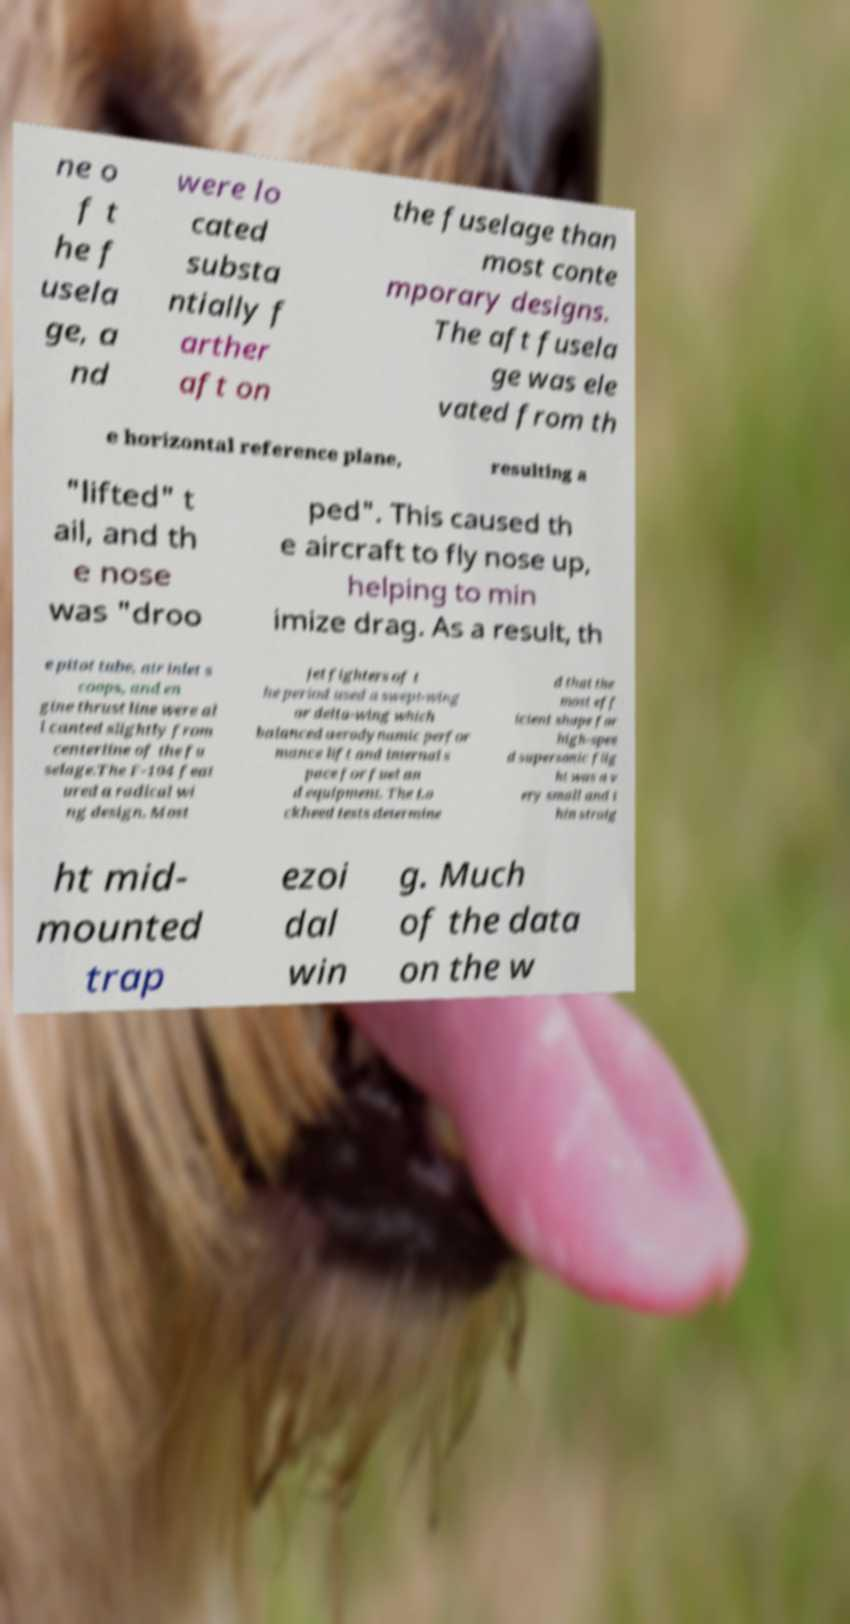There's text embedded in this image that I need extracted. Can you transcribe it verbatim? ne o f t he f usela ge, a nd were lo cated substa ntially f arther aft on the fuselage than most conte mporary designs. The aft fusela ge was ele vated from th e horizontal reference plane, resulting a "lifted" t ail, and th e nose was "droo ped". This caused th e aircraft to fly nose up, helping to min imize drag. As a result, th e pitot tube, air inlet s coops, and en gine thrust line were al l canted slightly from centerline of the fu selage.The F-104 feat ured a radical wi ng design. Most jet fighters of t he period used a swept-wing or delta-wing which balanced aerodynamic perfor mance lift and internal s pace for fuel an d equipment. The Lo ckheed tests determine d that the most eff icient shape for high-spee d supersonic flig ht was a v ery small and t hin straig ht mid- mounted trap ezoi dal win g. Much of the data on the w 